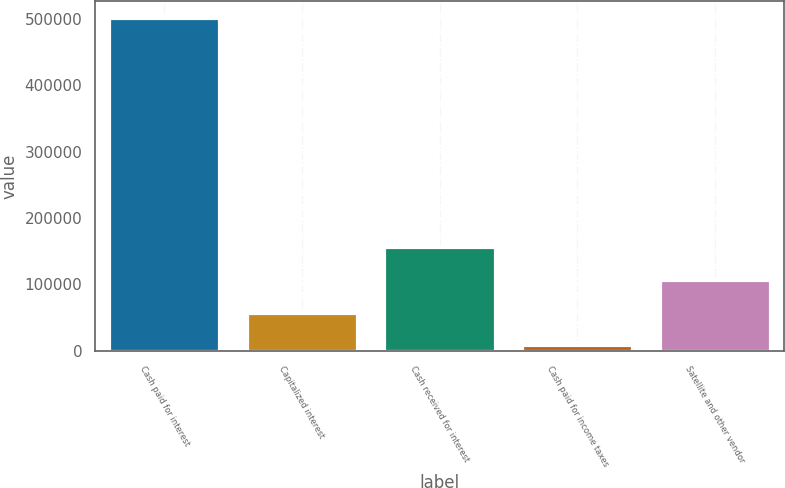Convert chart. <chart><loc_0><loc_0><loc_500><loc_500><bar_chart><fcel>Cash paid for interest<fcel>Capitalized interest<fcel>Cash received for interest<fcel>Cash paid for income taxes<fcel>Satellite and other vendor<nl><fcel>500879<fcel>57644.3<fcel>156141<fcel>8396<fcel>106893<nl></chart> 